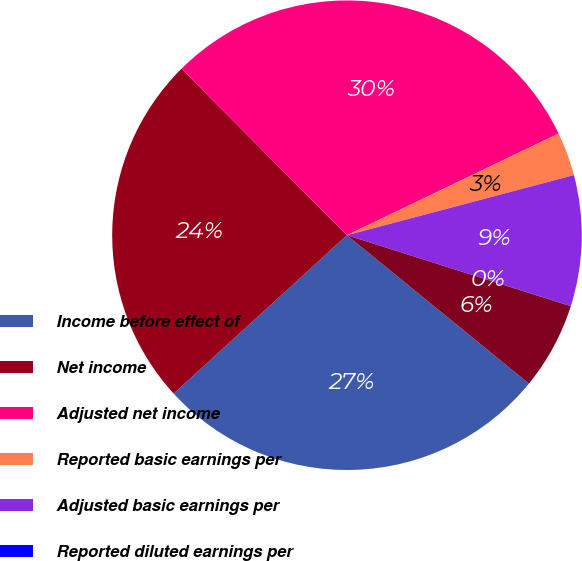Convert chart. <chart><loc_0><loc_0><loc_500><loc_500><pie_chart><fcel>Income before effect of<fcel>Net income<fcel>Adjusted net income<fcel>Reported basic earnings per<fcel>Adjusted basic earnings per<fcel>Reported diluted earnings per<fcel>Adjusted diluted earnings per<nl><fcel>27.33%<fcel>24.33%<fcel>30.32%<fcel>3.01%<fcel>9.0%<fcel>0.01%<fcel>6.0%<nl></chart> 